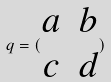Convert formula to latex. <formula><loc_0><loc_0><loc_500><loc_500>q = ( \begin{matrix} a & b \\ c & d \end{matrix} )</formula> 